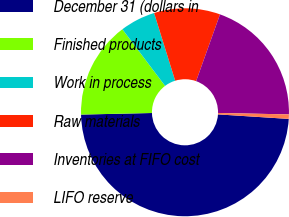Convert chart to OTSL. <chart><loc_0><loc_0><loc_500><loc_500><pie_chart><fcel>December 31 (dollars in<fcel>Finished products<fcel>Work in process<fcel>Raw materials<fcel>Inventories at FIFO cost<fcel>LIFO reserve<nl><fcel>48.63%<fcel>15.07%<fcel>5.48%<fcel>10.27%<fcel>19.86%<fcel>0.69%<nl></chart> 